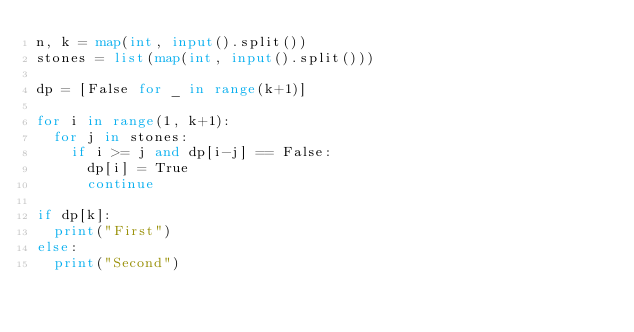<code> <loc_0><loc_0><loc_500><loc_500><_Python_>n, k = map(int, input().split())
stones = list(map(int, input().split()))

dp = [False for _ in range(k+1)]

for i in range(1, k+1):
  for j in stones:
    if i >= j and dp[i-j] == False:
      dp[i] = True
      continue
      
if dp[k]:
  print("First")
else:
  print("Second")</code> 